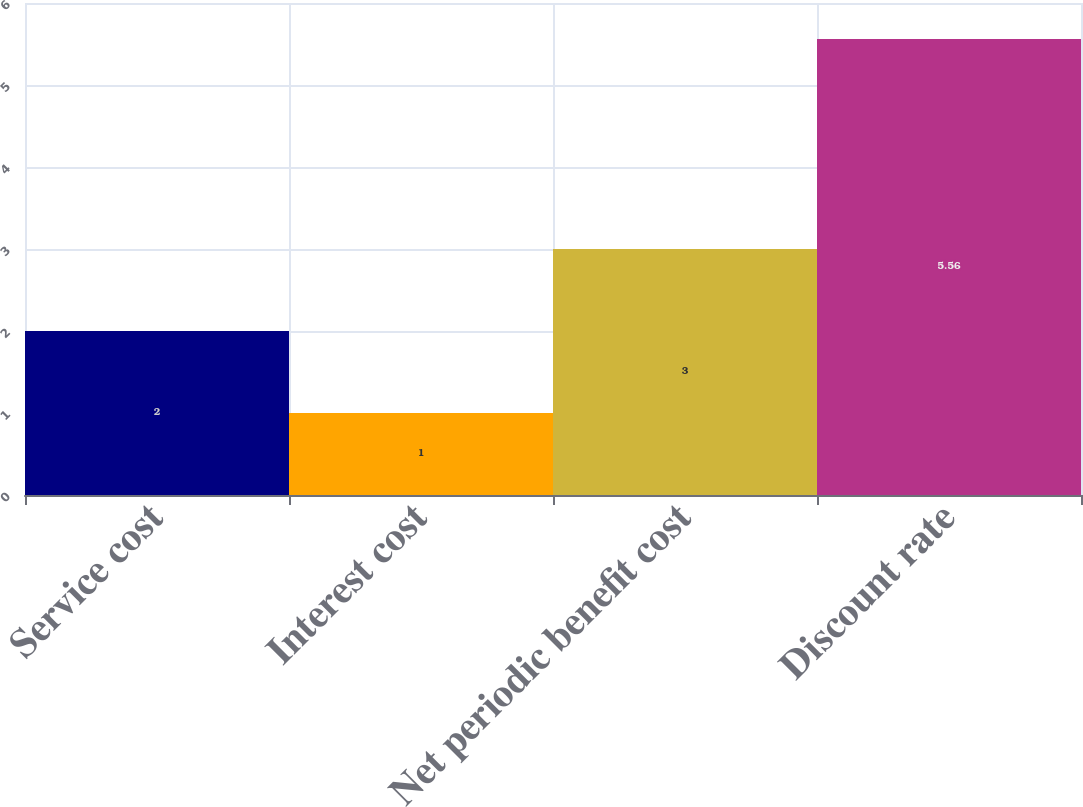<chart> <loc_0><loc_0><loc_500><loc_500><bar_chart><fcel>Service cost<fcel>Interest cost<fcel>Net periodic benefit cost<fcel>Discount rate<nl><fcel>2<fcel>1<fcel>3<fcel>5.56<nl></chart> 